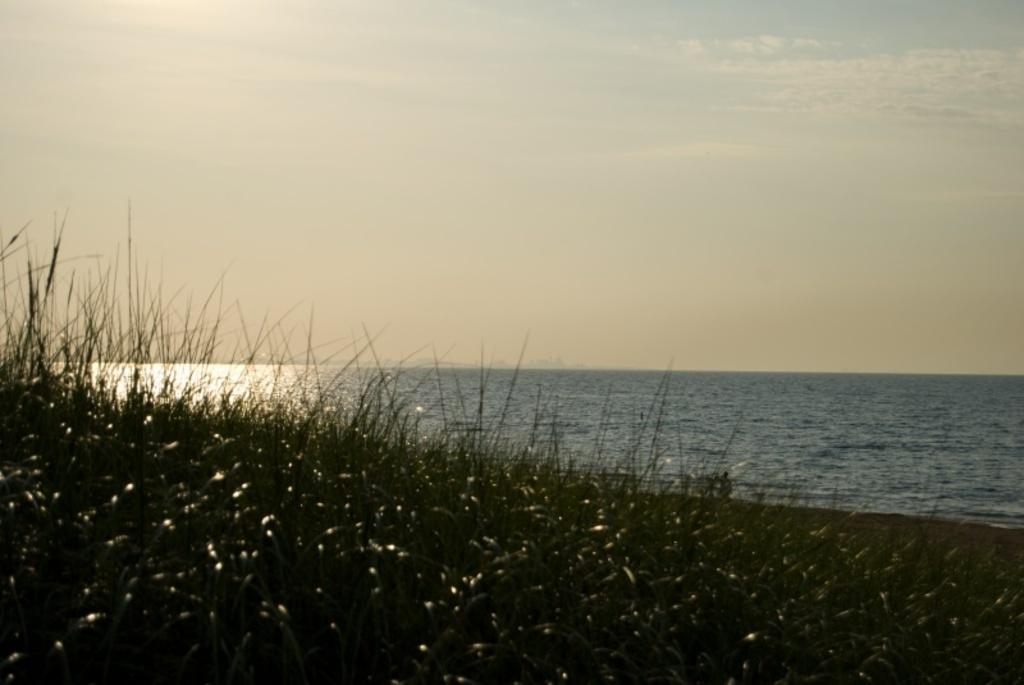What type of vegetation is present in the image? There is grass in the image. What else can be seen in the image besides grass? There is water and the sky visible in the image. Can you describe the sky in the image? The sky is visible in the image, but no specific details about its appearance are provided. What might be the location of the image based on the facts? The image may have been taken near the ocean, given the presence of water and the possibility of a coastal environment. What type of knife is being used to cut the grass in the image? There is no knife present in the image; the grass is not being cut. What type of river can be seen in the image? There is no river present in the image; only grass, water, and the sky are visible. 